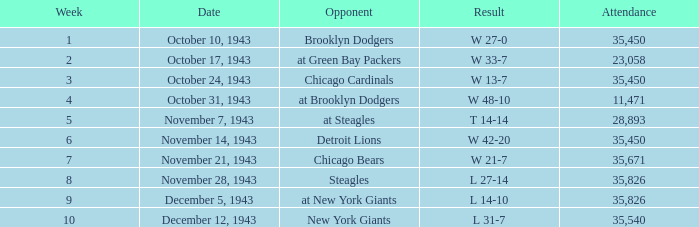What is the minimum week having an attendance exceeding 23,058, using october 24, 1943 as the date? 3.0. 